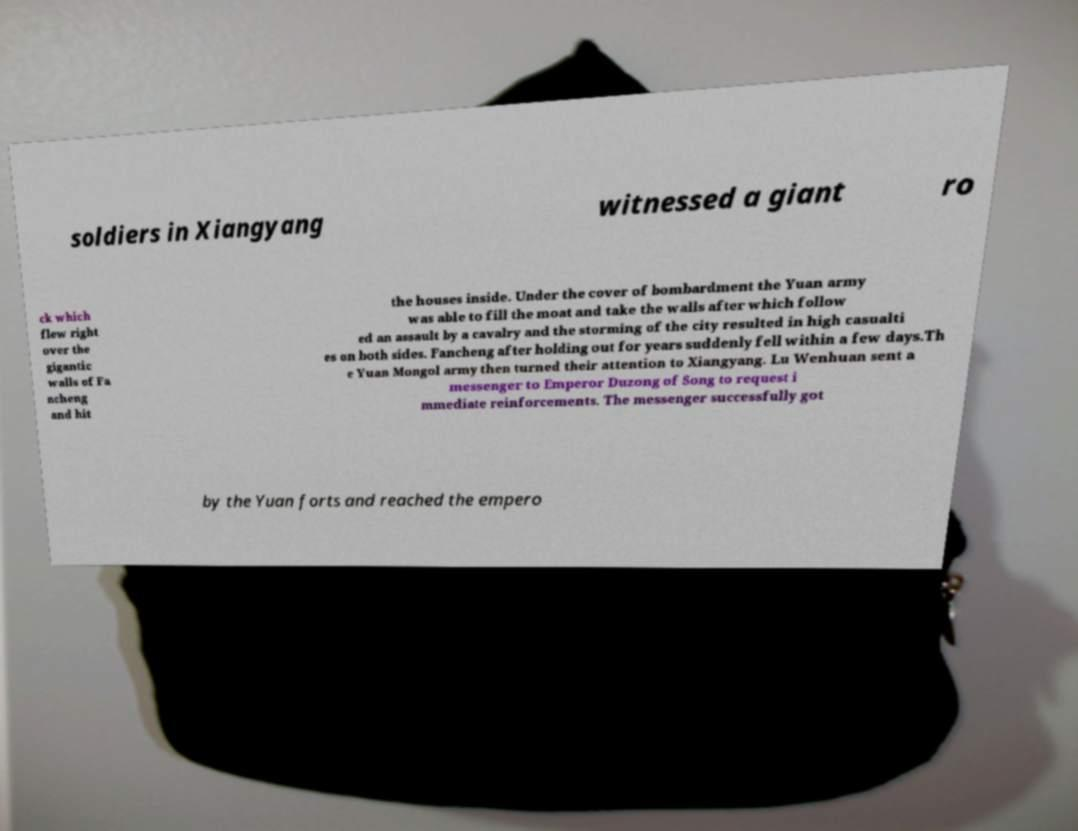Please identify and transcribe the text found in this image. soldiers in Xiangyang witnessed a giant ro ck which flew right over the gigantic walls of Fa ncheng and hit the houses inside. Under the cover of bombardment the Yuan army was able to fill the moat and take the walls after which follow ed an assault by a cavalry and the storming of the city resulted in high casualti es on both sides. Fancheng after holding out for years suddenly fell within a few days.Th e Yuan Mongol army then turned their attention to Xiangyang. Lu Wenhuan sent a messenger to Emperor Duzong of Song to request i mmediate reinforcements. The messenger successfully got by the Yuan forts and reached the empero 